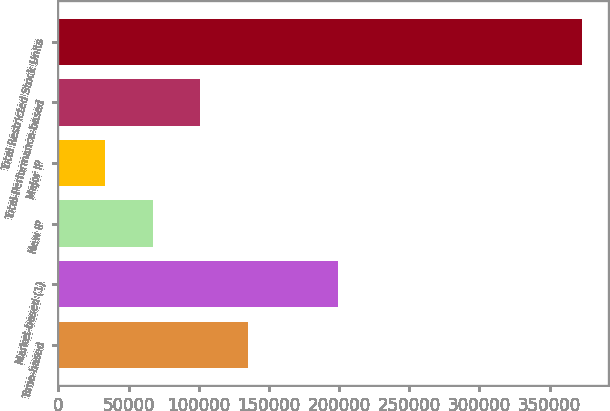Convert chart to OTSL. <chart><loc_0><loc_0><loc_500><loc_500><bar_chart><fcel>Time-based<fcel>Market-based (1)<fcel>New IP<fcel>Major IP<fcel>Total-Performance-based<fcel>Total Restricted Stock Units<nl><fcel>135101<fcel>199038<fcel>67148.3<fcel>33172<fcel>101125<fcel>372935<nl></chart> 